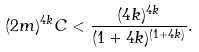<formula> <loc_0><loc_0><loc_500><loc_500>( 2 m ) ^ { 4 k } C < \frac { ( 4 k ) ^ { 4 k } } { ( 1 + 4 k ) ^ { ( 1 + 4 k ) } } .</formula> 